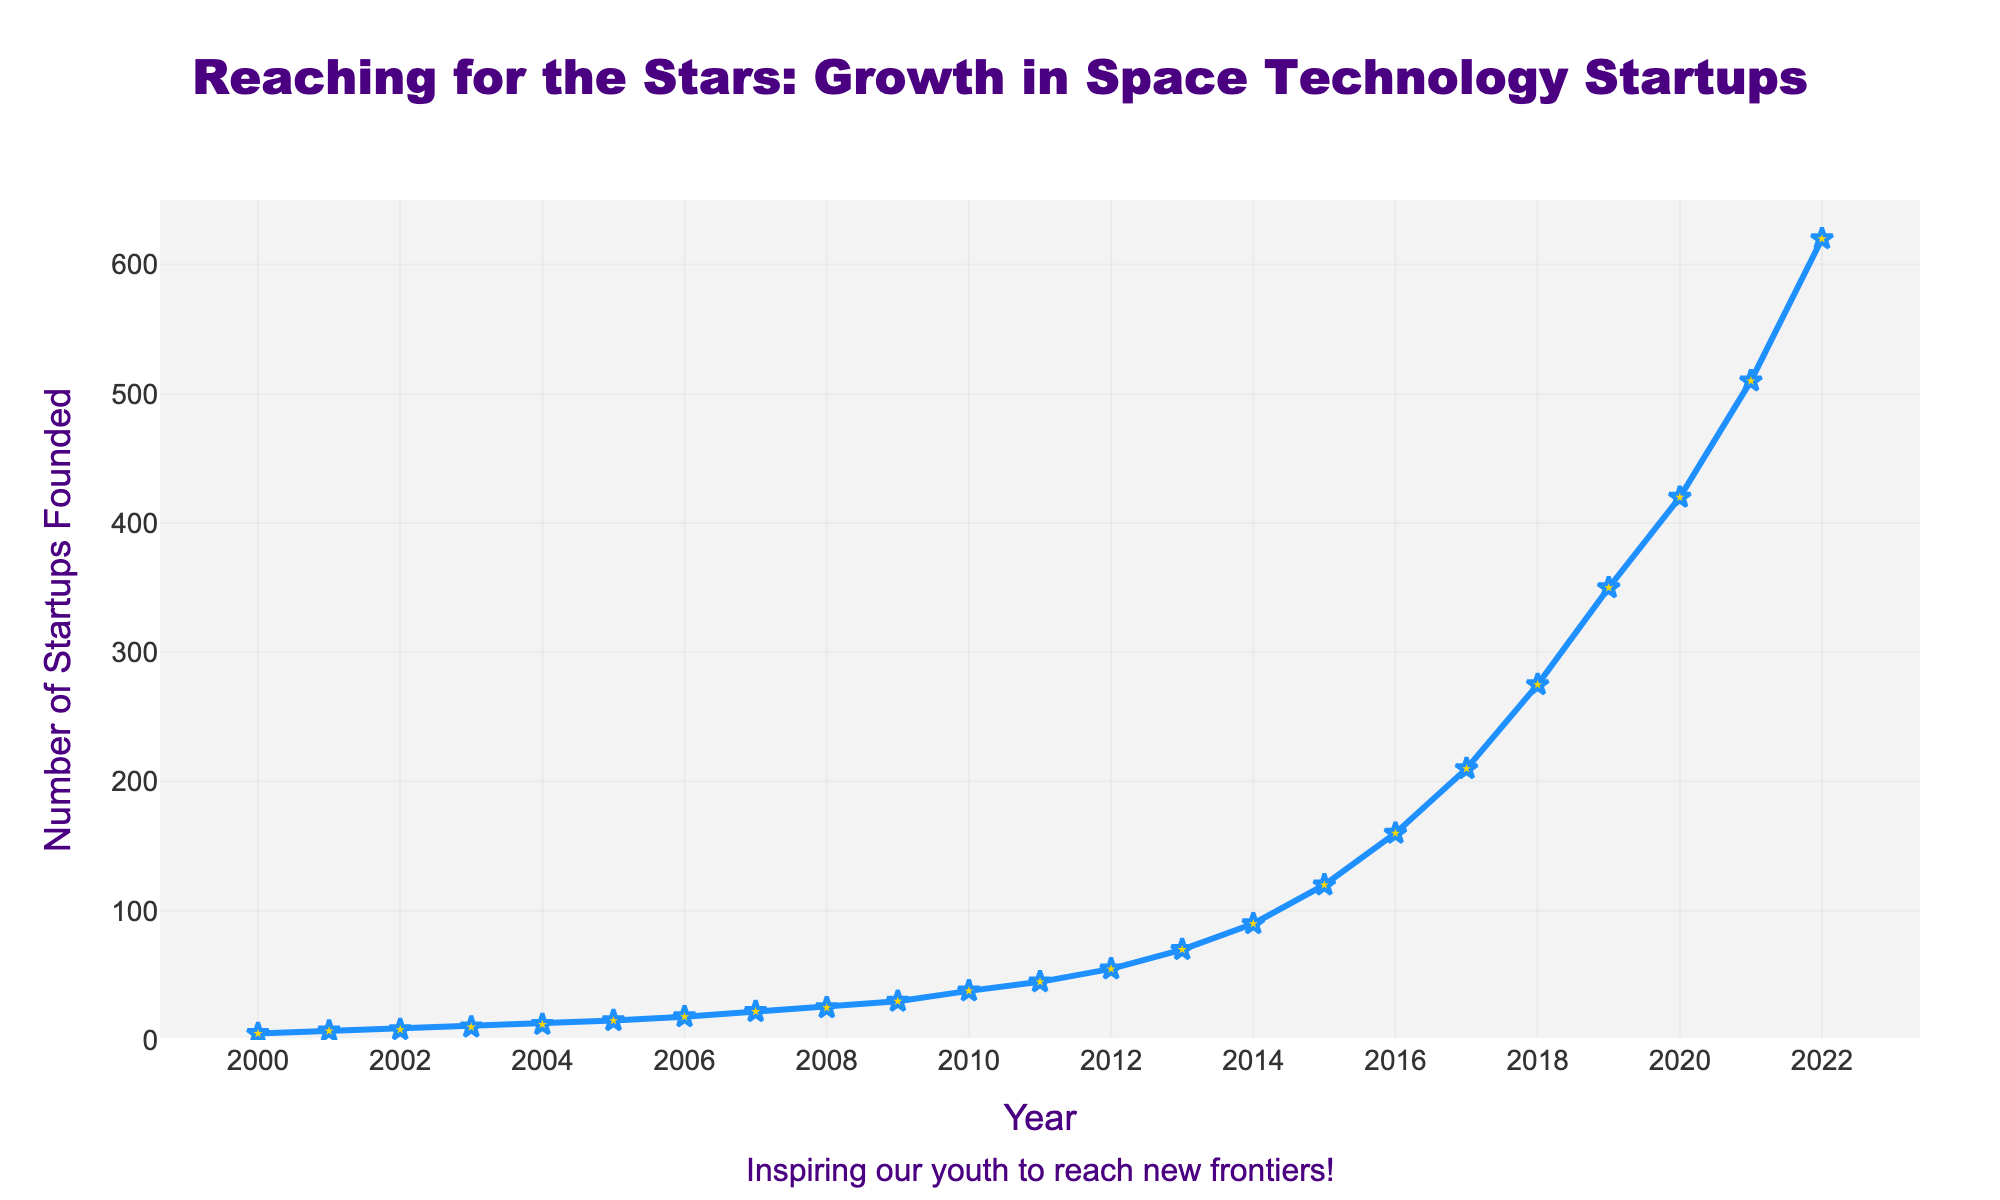What's the total number of space technology startups founded between 2000 and 2010? Summing the values for each year from 2000 to 2010: 5 + 7 + 8 + 10 + 12 + 15 + 18 + 22 + 25 + 30 + 38 = 190
Answer: 190 Which year had the highest growth in the number of space technology startups founded compared to the previous year? By calculating the yearly differences: 2 (2001), 1 (2002), 2 (2003), 2 (2004), 3 (2005), 3 (2006), 4 (2007), 3 (2008), 5 (2009), 8 (2010), 7 (2011), 10 (2012), 15 (2013), 20 (2014), 30 (2015), 40 (2016), 50 (2017), 65 (2018), 75 (2019), 70 (2020), 90 (2021), 110 (2022). The highest growth is 110 in 2022
Answer: 2022 What's the average annual number of space technology startups founded from 2015 to 2020? Summing the values for each year from 2015 to 2020 and then dividing by the number of years: (120 + 160 + 210 + 275 + 350 + 420) / 6 = 253.33
Answer: 253.33 How does the number of startups founded in 2010 compare to the number founded in 2005? The number of startups founded in 2010 is 38 and in 2005 is 15. Since 38 > 15, the number of startups founded in 2010 is greater.
Answer: 38 > 15 Between which consecutive years was the first significant increase (greater than 10) observed in the number of space technology startups founded? Checking yearly differences until the first time the increase is greater than 10: 2 (2001), 1 (2002), 2 (2003), 2 (2004), 3 (2005), 3 (2006), 4 (2007), 3 (2008), 5 (2009), 8 (2010), 7 (2011), 10 (2012), 15 (2013). The first increase greater than 10 is from 2012 to 2013.
Answer: 2012 to 2013 What is the overall trend in the number of space technology startups founded from 2000 to 2022? Observing the line plot, the number of startups increases steadily and significantly over the 22 years, showing an upward trend throughout the period.
Answer: Upward trend If you look at the trend line, which years had the most significant acceleration in the number of startups founded? By identifying the steepest slopes in the plot, the most significant accelerations are apparent between 2014 and 2022, with notable increases specifically in 2015, 2016, 2017, 2018, 2019, and 2021.
Answer: 2014 to 2022 How many more startups were founded in 2022 compared to the total number founded from 2000 to 2005? Summing startups from 2000 to 2005: 5 + 7 + 8 + 10 + 12 + 15 = 57. Difference with startups founded in 2022 (620): 620 - 57 = 563
Answer: 563 